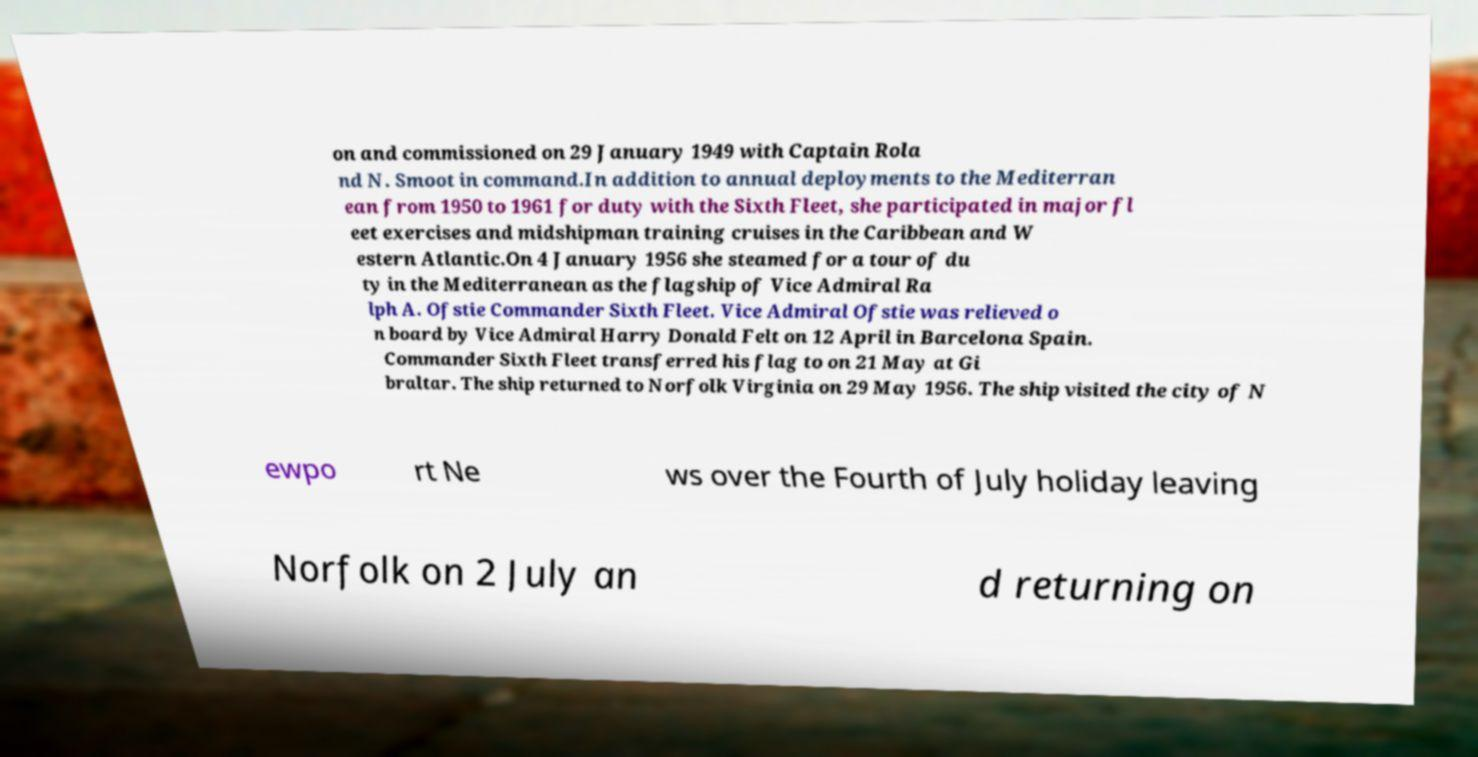Please identify and transcribe the text found in this image. on and commissioned on 29 January 1949 with Captain Rola nd N. Smoot in command.In addition to annual deployments to the Mediterran ean from 1950 to 1961 for duty with the Sixth Fleet, she participated in major fl eet exercises and midshipman training cruises in the Caribbean and W estern Atlantic.On 4 January 1956 she steamed for a tour of du ty in the Mediterranean as the flagship of Vice Admiral Ra lph A. Ofstie Commander Sixth Fleet. Vice Admiral Ofstie was relieved o n board by Vice Admiral Harry Donald Felt on 12 April in Barcelona Spain. Commander Sixth Fleet transferred his flag to on 21 May at Gi braltar. The ship returned to Norfolk Virginia on 29 May 1956. The ship visited the city of N ewpo rt Ne ws over the Fourth of July holiday leaving Norfolk on 2 July an d returning on 